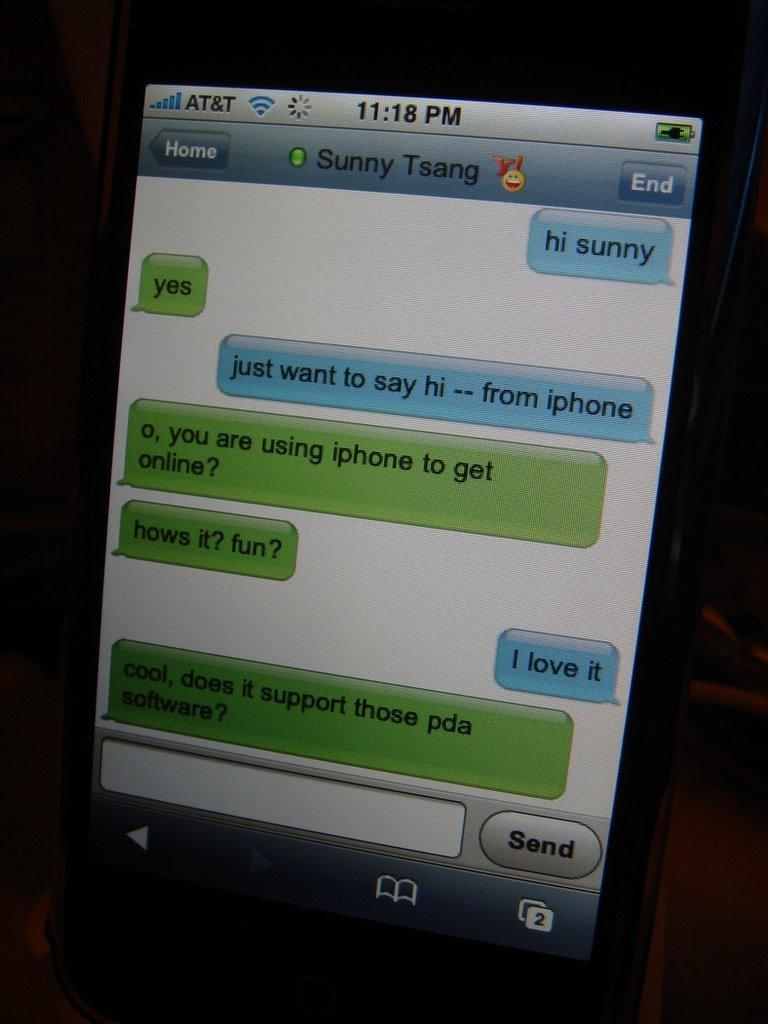<image>
Relay a brief, clear account of the picture shown. An iphone text conversation with Sunny Tsang at 11:18 PM 